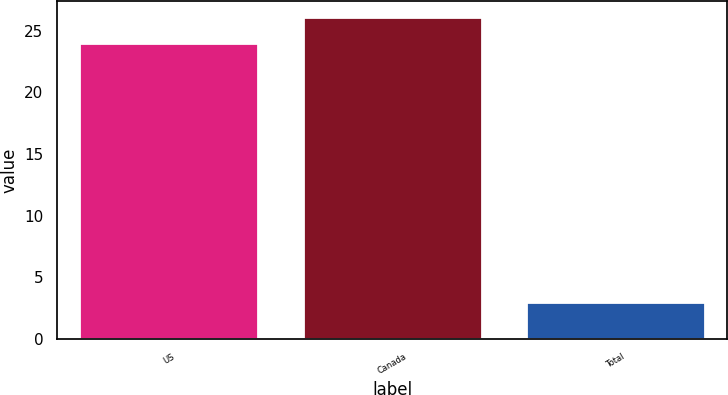<chart> <loc_0><loc_0><loc_500><loc_500><bar_chart><fcel>US<fcel>Canada<fcel>Total<nl><fcel>24<fcel>26.1<fcel>3<nl></chart> 